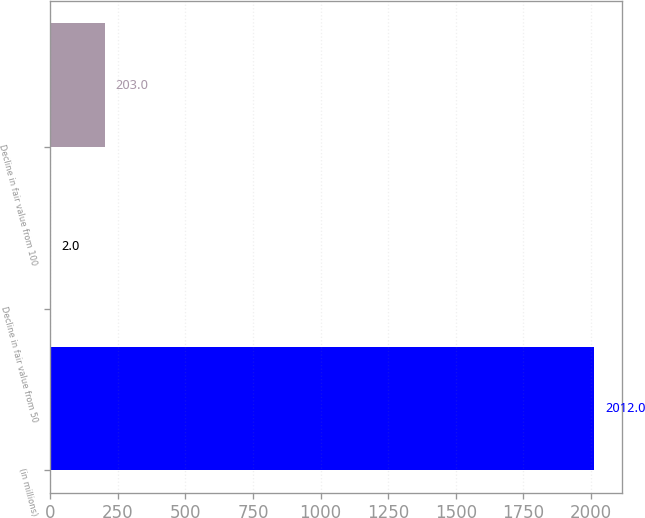Convert chart. <chart><loc_0><loc_0><loc_500><loc_500><bar_chart><fcel>(in millions)<fcel>Decline in fair value from 50<fcel>Decline in fair value from 100<nl><fcel>2012<fcel>2<fcel>203<nl></chart> 